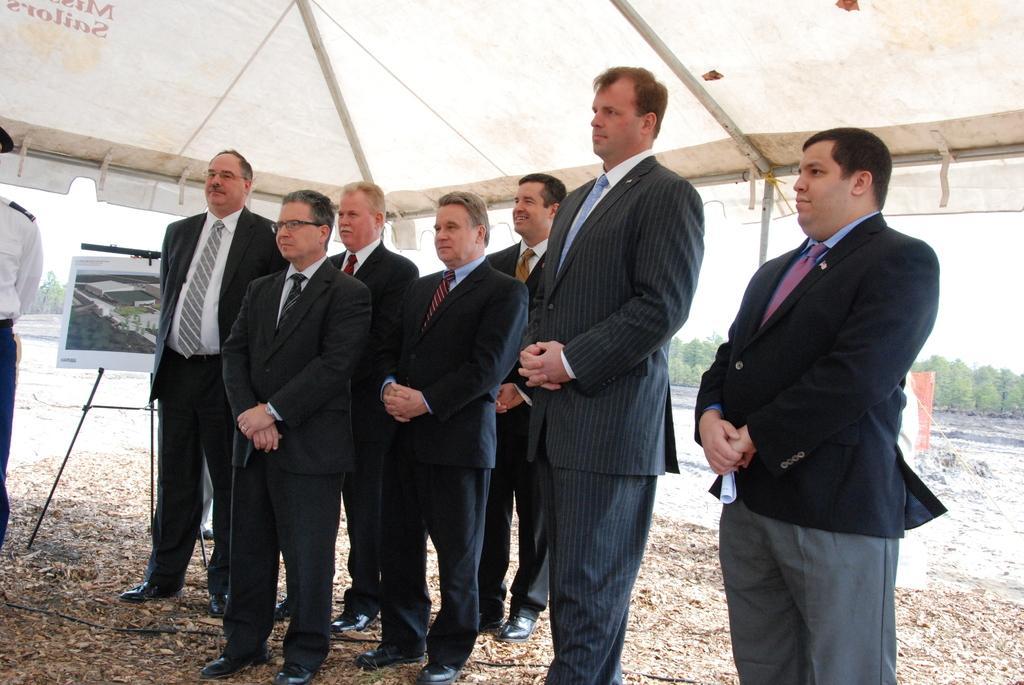In one or two sentences, can you explain what this image depicts? In this picture we can see a group of people standing under a tent, there is a picture frame on a stand, there are few leaves, few trees and a wire on the ground. 